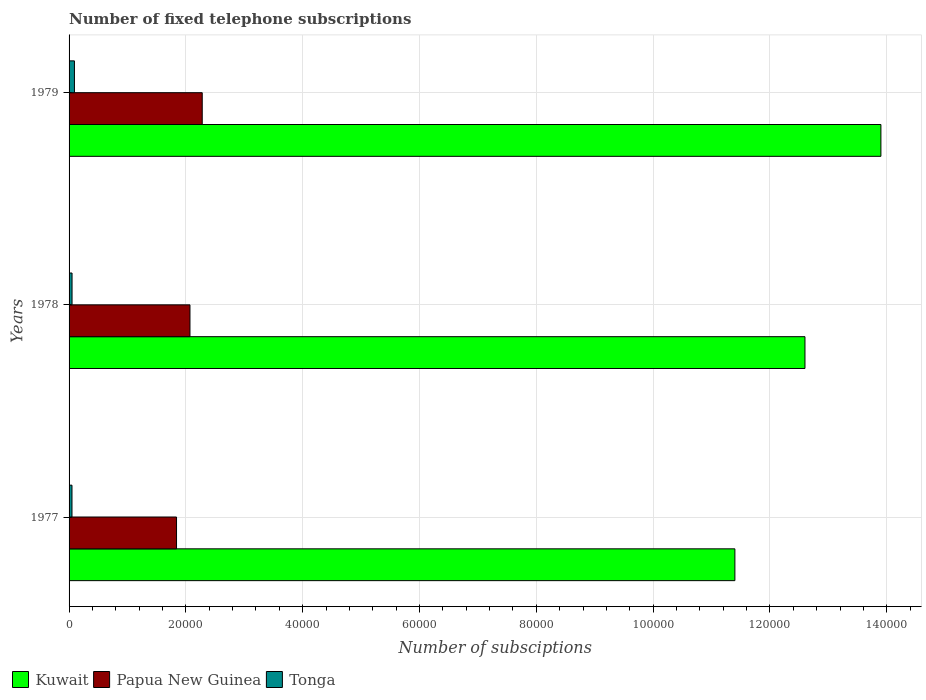How many groups of bars are there?
Give a very brief answer. 3. Are the number of bars per tick equal to the number of legend labels?
Keep it short and to the point. Yes. What is the label of the 1st group of bars from the top?
Your response must be concise. 1979. What is the number of fixed telephone subscriptions in Kuwait in 1978?
Provide a short and direct response. 1.26e+05. Across all years, what is the maximum number of fixed telephone subscriptions in Tonga?
Make the answer very short. 920. Across all years, what is the minimum number of fixed telephone subscriptions in Kuwait?
Your response must be concise. 1.14e+05. In which year was the number of fixed telephone subscriptions in Papua New Guinea maximum?
Your response must be concise. 1979. What is the total number of fixed telephone subscriptions in Tonga in the graph?
Your answer should be compact. 1930. What is the difference between the number of fixed telephone subscriptions in Papua New Guinea in 1978 and that in 1979?
Your answer should be compact. -2100. What is the difference between the number of fixed telephone subscriptions in Tonga in 1979 and the number of fixed telephone subscriptions in Kuwait in 1977?
Your answer should be very brief. -1.13e+05. What is the average number of fixed telephone subscriptions in Kuwait per year?
Provide a succinct answer. 1.26e+05. In the year 1977, what is the difference between the number of fixed telephone subscriptions in Tonga and number of fixed telephone subscriptions in Kuwait?
Provide a short and direct response. -1.14e+05. In how many years, is the number of fixed telephone subscriptions in Papua New Guinea greater than 4000 ?
Provide a succinct answer. 3. What is the ratio of the number of fixed telephone subscriptions in Tonga in 1977 to that in 1979?
Provide a succinct answer. 0.54. Is the difference between the number of fixed telephone subscriptions in Tonga in 1978 and 1979 greater than the difference between the number of fixed telephone subscriptions in Kuwait in 1978 and 1979?
Provide a short and direct response. Yes. What is the difference between the highest and the second highest number of fixed telephone subscriptions in Kuwait?
Ensure brevity in your answer.  1.30e+04. What is the difference between the highest and the lowest number of fixed telephone subscriptions in Tonga?
Keep it short and to the point. 420. In how many years, is the number of fixed telephone subscriptions in Tonga greater than the average number of fixed telephone subscriptions in Tonga taken over all years?
Ensure brevity in your answer.  1. Is the sum of the number of fixed telephone subscriptions in Papua New Guinea in 1977 and 1979 greater than the maximum number of fixed telephone subscriptions in Tonga across all years?
Provide a succinct answer. Yes. What does the 3rd bar from the top in 1978 represents?
Provide a succinct answer. Kuwait. What does the 3rd bar from the bottom in 1979 represents?
Your answer should be compact. Tonga. What is the difference between two consecutive major ticks on the X-axis?
Offer a terse response. 2.00e+04. Are the values on the major ticks of X-axis written in scientific E-notation?
Give a very brief answer. No. Does the graph contain any zero values?
Offer a very short reply. No. Where does the legend appear in the graph?
Ensure brevity in your answer.  Bottom left. How many legend labels are there?
Keep it short and to the point. 3. How are the legend labels stacked?
Provide a succinct answer. Horizontal. What is the title of the graph?
Keep it short and to the point. Number of fixed telephone subscriptions. What is the label or title of the X-axis?
Your answer should be very brief. Number of subsciptions. What is the label or title of the Y-axis?
Your response must be concise. Years. What is the Number of subsciptions in Kuwait in 1977?
Make the answer very short. 1.14e+05. What is the Number of subsciptions of Papua New Guinea in 1977?
Give a very brief answer. 1.84e+04. What is the Number of subsciptions of Kuwait in 1978?
Keep it short and to the point. 1.26e+05. What is the Number of subsciptions of Papua New Guinea in 1978?
Give a very brief answer. 2.07e+04. What is the Number of subsciptions of Tonga in 1978?
Provide a succinct answer. 510. What is the Number of subsciptions in Kuwait in 1979?
Provide a succinct answer. 1.39e+05. What is the Number of subsciptions of Papua New Guinea in 1979?
Give a very brief answer. 2.28e+04. What is the Number of subsciptions in Tonga in 1979?
Keep it short and to the point. 920. Across all years, what is the maximum Number of subsciptions in Kuwait?
Provide a succinct answer. 1.39e+05. Across all years, what is the maximum Number of subsciptions in Papua New Guinea?
Your answer should be compact. 2.28e+04. Across all years, what is the maximum Number of subsciptions in Tonga?
Offer a terse response. 920. Across all years, what is the minimum Number of subsciptions of Kuwait?
Your answer should be very brief. 1.14e+05. Across all years, what is the minimum Number of subsciptions in Papua New Guinea?
Give a very brief answer. 1.84e+04. What is the total Number of subsciptions of Kuwait in the graph?
Provide a succinct answer. 3.79e+05. What is the total Number of subsciptions in Papua New Guinea in the graph?
Make the answer very short. 6.19e+04. What is the total Number of subsciptions of Tonga in the graph?
Your answer should be compact. 1930. What is the difference between the Number of subsciptions of Kuwait in 1977 and that in 1978?
Provide a succinct answer. -1.20e+04. What is the difference between the Number of subsciptions in Papua New Guinea in 1977 and that in 1978?
Your answer should be very brief. -2300. What is the difference between the Number of subsciptions of Tonga in 1977 and that in 1978?
Your response must be concise. -10. What is the difference between the Number of subsciptions in Kuwait in 1977 and that in 1979?
Give a very brief answer. -2.50e+04. What is the difference between the Number of subsciptions in Papua New Guinea in 1977 and that in 1979?
Give a very brief answer. -4400. What is the difference between the Number of subsciptions of Tonga in 1977 and that in 1979?
Offer a terse response. -420. What is the difference between the Number of subsciptions in Kuwait in 1978 and that in 1979?
Provide a succinct answer. -1.30e+04. What is the difference between the Number of subsciptions in Papua New Guinea in 1978 and that in 1979?
Offer a very short reply. -2100. What is the difference between the Number of subsciptions in Tonga in 1978 and that in 1979?
Provide a short and direct response. -410. What is the difference between the Number of subsciptions in Kuwait in 1977 and the Number of subsciptions in Papua New Guinea in 1978?
Offer a terse response. 9.33e+04. What is the difference between the Number of subsciptions in Kuwait in 1977 and the Number of subsciptions in Tonga in 1978?
Give a very brief answer. 1.13e+05. What is the difference between the Number of subsciptions in Papua New Guinea in 1977 and the Number of subsciptions in Tonga in 1978?
Offer a terse response. 1.79e+04. What is the difference between the Number of subsciptions in Kuwait in 1977 and the Number of subsciptions in Papua New Guinea in 1979?
Give a very brief answer. 9.12e+04. What is the difference between the Number of subsciptions of Kuwait in 1977 and the Number of subsciptions of Tonga in 1979?
Make the answer very short. 1.13e+05. What is the difference between the Number of subsciptions in Papua New Guinea in 1977 and the Number of subsciptions in Tonga in 1979?
Your answer should be very brief. 1.75e+04. What is the difference between the Number of subsciptions in Kuwait in 1978 and the Number of subsciptions in Papua New Guinea in 1979?
Provide a succinct answer. 1.03e+05. What is the difference between the Number of subsciptions in Kuwait in 1978 and the Number of subsciptions in Tonga in 1979?
Your response must be concise. 1.25e+05. What is the difference between the Number of subsciptions in Papua New Guinea in 1978 and the Number of subsciptions in Tonga in 1979?
Provide a succinct answer. 1.98e+04. What is the average Number of subsciptions of Kuwait per year?
Offer a very short reply. 1.26e+05. What is the average Number of subsciptions of Papua New Guinea per year?
Your answer should be very brief. 2.06e+04. What is the average Number of subsciptions of Tonga per year?
Make the answer very short. 643.33. In the year 1977, what is the difference between the Number of subsciptions of Kuwait and Number of subsciptions of Papua New Guinea?
Ensure brevity in your answer.  9.56e+04. In the year 1977, what is the difference between the Number of subsciptions in Kuwait and Number of subsciptions in Tonga?
Ensure brevity in your answer.  1.14e+05. In the year 1977, what is the difference between the Number of subsciptions of Papua New Guinea and Number of subsciptions of Tonga?
Give a very brief answer. 1.79e+04. In the year 1978, what is the difference between the Number of subsciptions in Kuwait and Number of subsciptions in Papua New Guinea?
Your response must be concise. 1.05e+05. In the year 1978, what is the difference between the Number of subsciptions of Kuwait and Number of subsciptions of Tonga?
Your answer should be compact. 1.25e+05. In the year 1978, what is the difference between the Number of subsciptions in Papua New Guinea and Number of subsciptions in Tonga?
Your answer should be compact. 2.02e+04. In the year 1979, what is the difference between the Number of subsciptions in Kuwait and Number of subsciptions in Papua New Guinea?
Your answer should be compact. 1.16e+05. In the year 1979, what is the difference between the Number of subsciptions in Kuwait and Number of subsciptions in Tonga?
Give a very brief answer. 1.38e+05. In the year 1979, what is the difference between the Number of subsciptions of Papua New Guinea and Number of subsciptions of Tonga?
Provide a succinct answer. 2.19e+04. What is the ratio of the Number of subsciptions in Kuwait in 1977 to that in 1978?
Provide a short and direct response. 0.9. What is the ratio of the Number of subsciptions of Tonga in 1977 to that in 1978?
Your answer should be compact. 0.98. What is the ratio of the Number of subsciptions of Kuwait in 1977 to that in 1979?
Your answer should be very brief. 0.82. What is the ratio of the Number of subsciptions of Papua New Guinea in 1977 to that in 1979?
Make the answer very short. 0.81. What is the ratio of the Number of subsciptions of Tonga in 1977 to that in 1979?
Ensure brevity in your answer.  0.54. What is the ratio of the Number of subsciptions in Kuwait in 1978 to that in 1979?
Offer a very short reply. 0.91. What is the ratio of the Number of subsciptions in Papua New Guinea in 1978 to that in 1979?
Your answer should be compact. 0.91. What is the ratio of the Number of subsciptions in Tonga in 1978 to that in 1979?
Give a very brief answer. 0.55. What is the difference between the highest and the second highest Number of subsciptions in Kuwait?
Make the answer very short. 1.30e+04. What is the difference between the highest and the second highest Number of subsciptions of Papua New Guinea?
Give a very brief answer. 2100. What is the difference between the highest and the second highest Number of subsciptions of Tonga?
Ensure brevity in your answer.  410. What is the difference between the highest and the lowest Number of subsciptions of Kuwait?
Your answer should be very brief. 2.50e+04. What is the difference between the highest and the lowest Number of subsciptions in Papua New Guinea?
Your answer should be compact. 4400. What is the difference between the highest and the lowest Number of subsciptions in Tonga?
Keep it short and to the point. 420. 